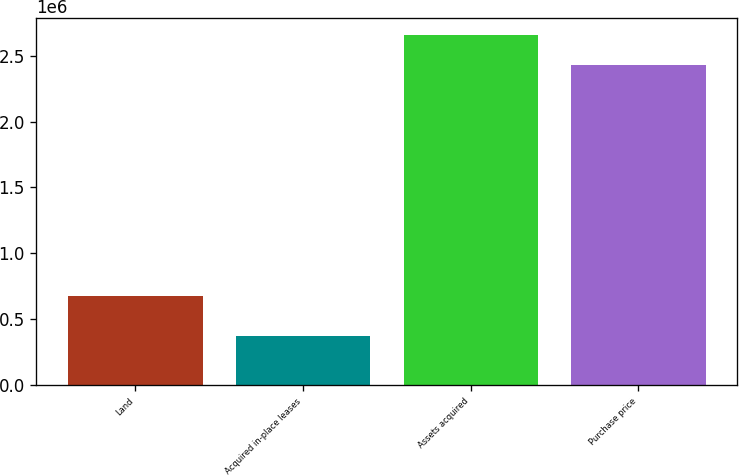<chart> <loc_0><loc_0><loc_500><loc_500><bar_chart><fcel>Land<fcel>Acquired in-place leases<fcel>Assets acquired<fcel>Purchase price<nl><fcel>675776<fcel>366949<fcel>2.65327e+06<fcel>2.42836e+06<nl></chart> 